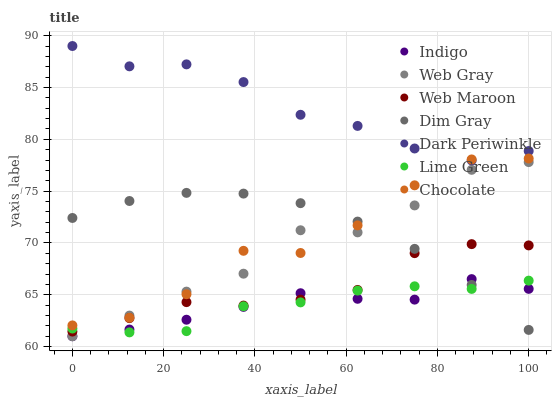Does Lime Green have the minimum area under the curve?
Answer yes or no. Yes. Does Dark Periwinkle have the maximum area under the curve?
Answer yes or no. Yes. Does Indigo have the minimum area under the curve?
Answer yes or no. No. Does Indigo have the maximum area under the curve?
Answer yes or no. No. Is Dim Gray the smoothest?
Answer yes or no. Yes. Is Chocolate the roughest?
Answer yes or no. Yes. Is Indigo the smoothest?
Answer yes or no. No. Is Indigo the roughest?
Answer yes or no. No. Does Indigo have the lowest value?
Answer yes or no. Yes. Does Web Maroon have the lowest value?
Answer yes or no. No. Does Dark Periwinkle have the highest value?
Answer yes or no. Yes. Does Indigo have the highest value?
Answer yes or no. No. Is Indigo less than Dark Periwinkle?
Answer yes or no. Yes. Is Dark Periwinkle greater than Web Gray?
Answer yes or no. Yes. Does Chocolate intersect Dark Periwinkle?
Answer yes or no. Yes. Is Chocolate less than Dark Periwinkle?
Answer yes or no. No. Is Chocolate greater than Dark Periwinkle?
Answer yes or no. No. Does Indigo intersect Dark Periwinkle?
Answer yes or no. No. 